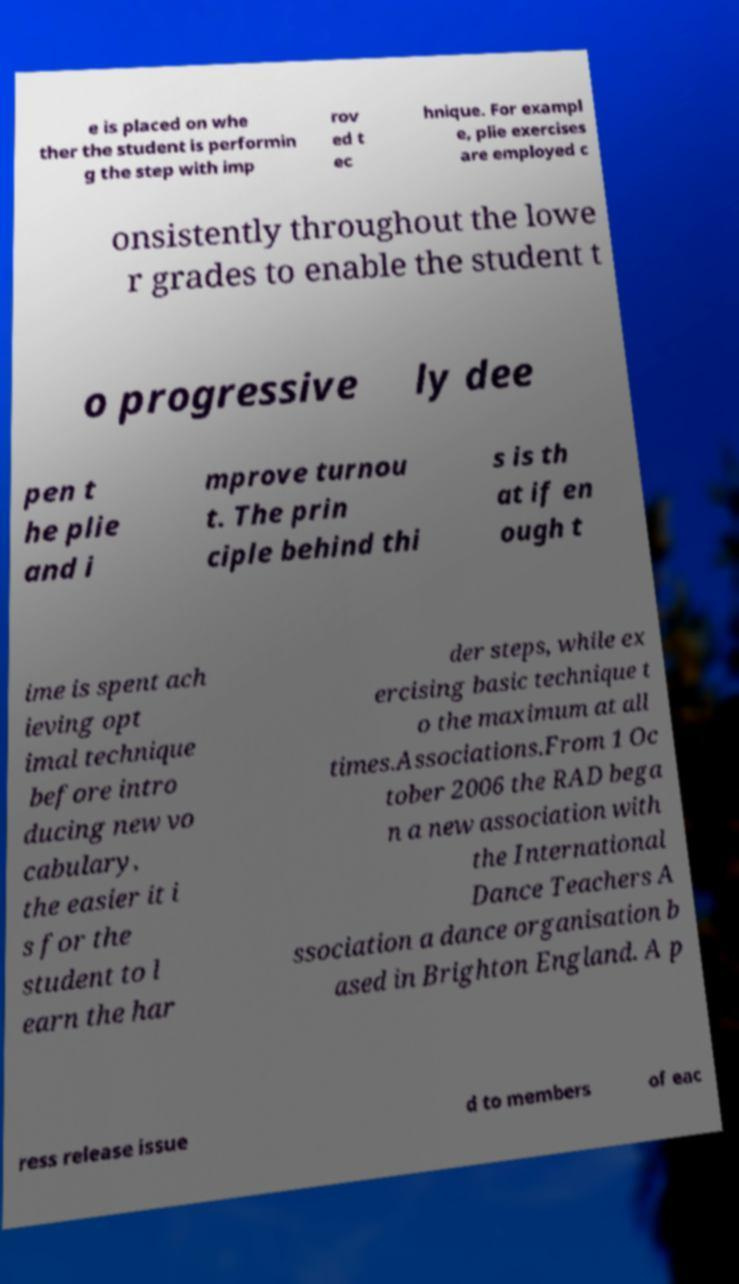Can you read and provide the text displayed in the image?This photo seems to have some interesting text. Can you extract and type it out for me? e is placed on whe ther the student is performin g the step with imp rov ed t ec hnique. For exampl e, plie exercises are employed c onsistently throughout the lowe r grades to enable the student t o progressive ly dee pen t he plie and i mprove turnou t. The prin ciple behind thi s is th at if en ough t ime is spent ach ieving opt imal technique before intro ducing new vo cabulary, the easier it i s for the student to l earn the har der steps, while ex ercising basic technique t o the maximum at all times.Associations.From 1 Oc tober 2006 the RAD bega n a new association with the International Dance Teachers A ssociation a dance organisation b ased in Brighton England. A p ress release issue d to members of eac 